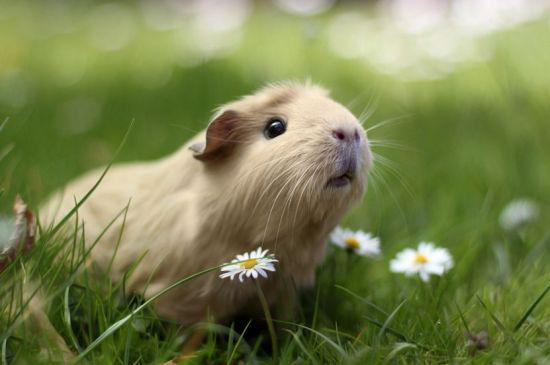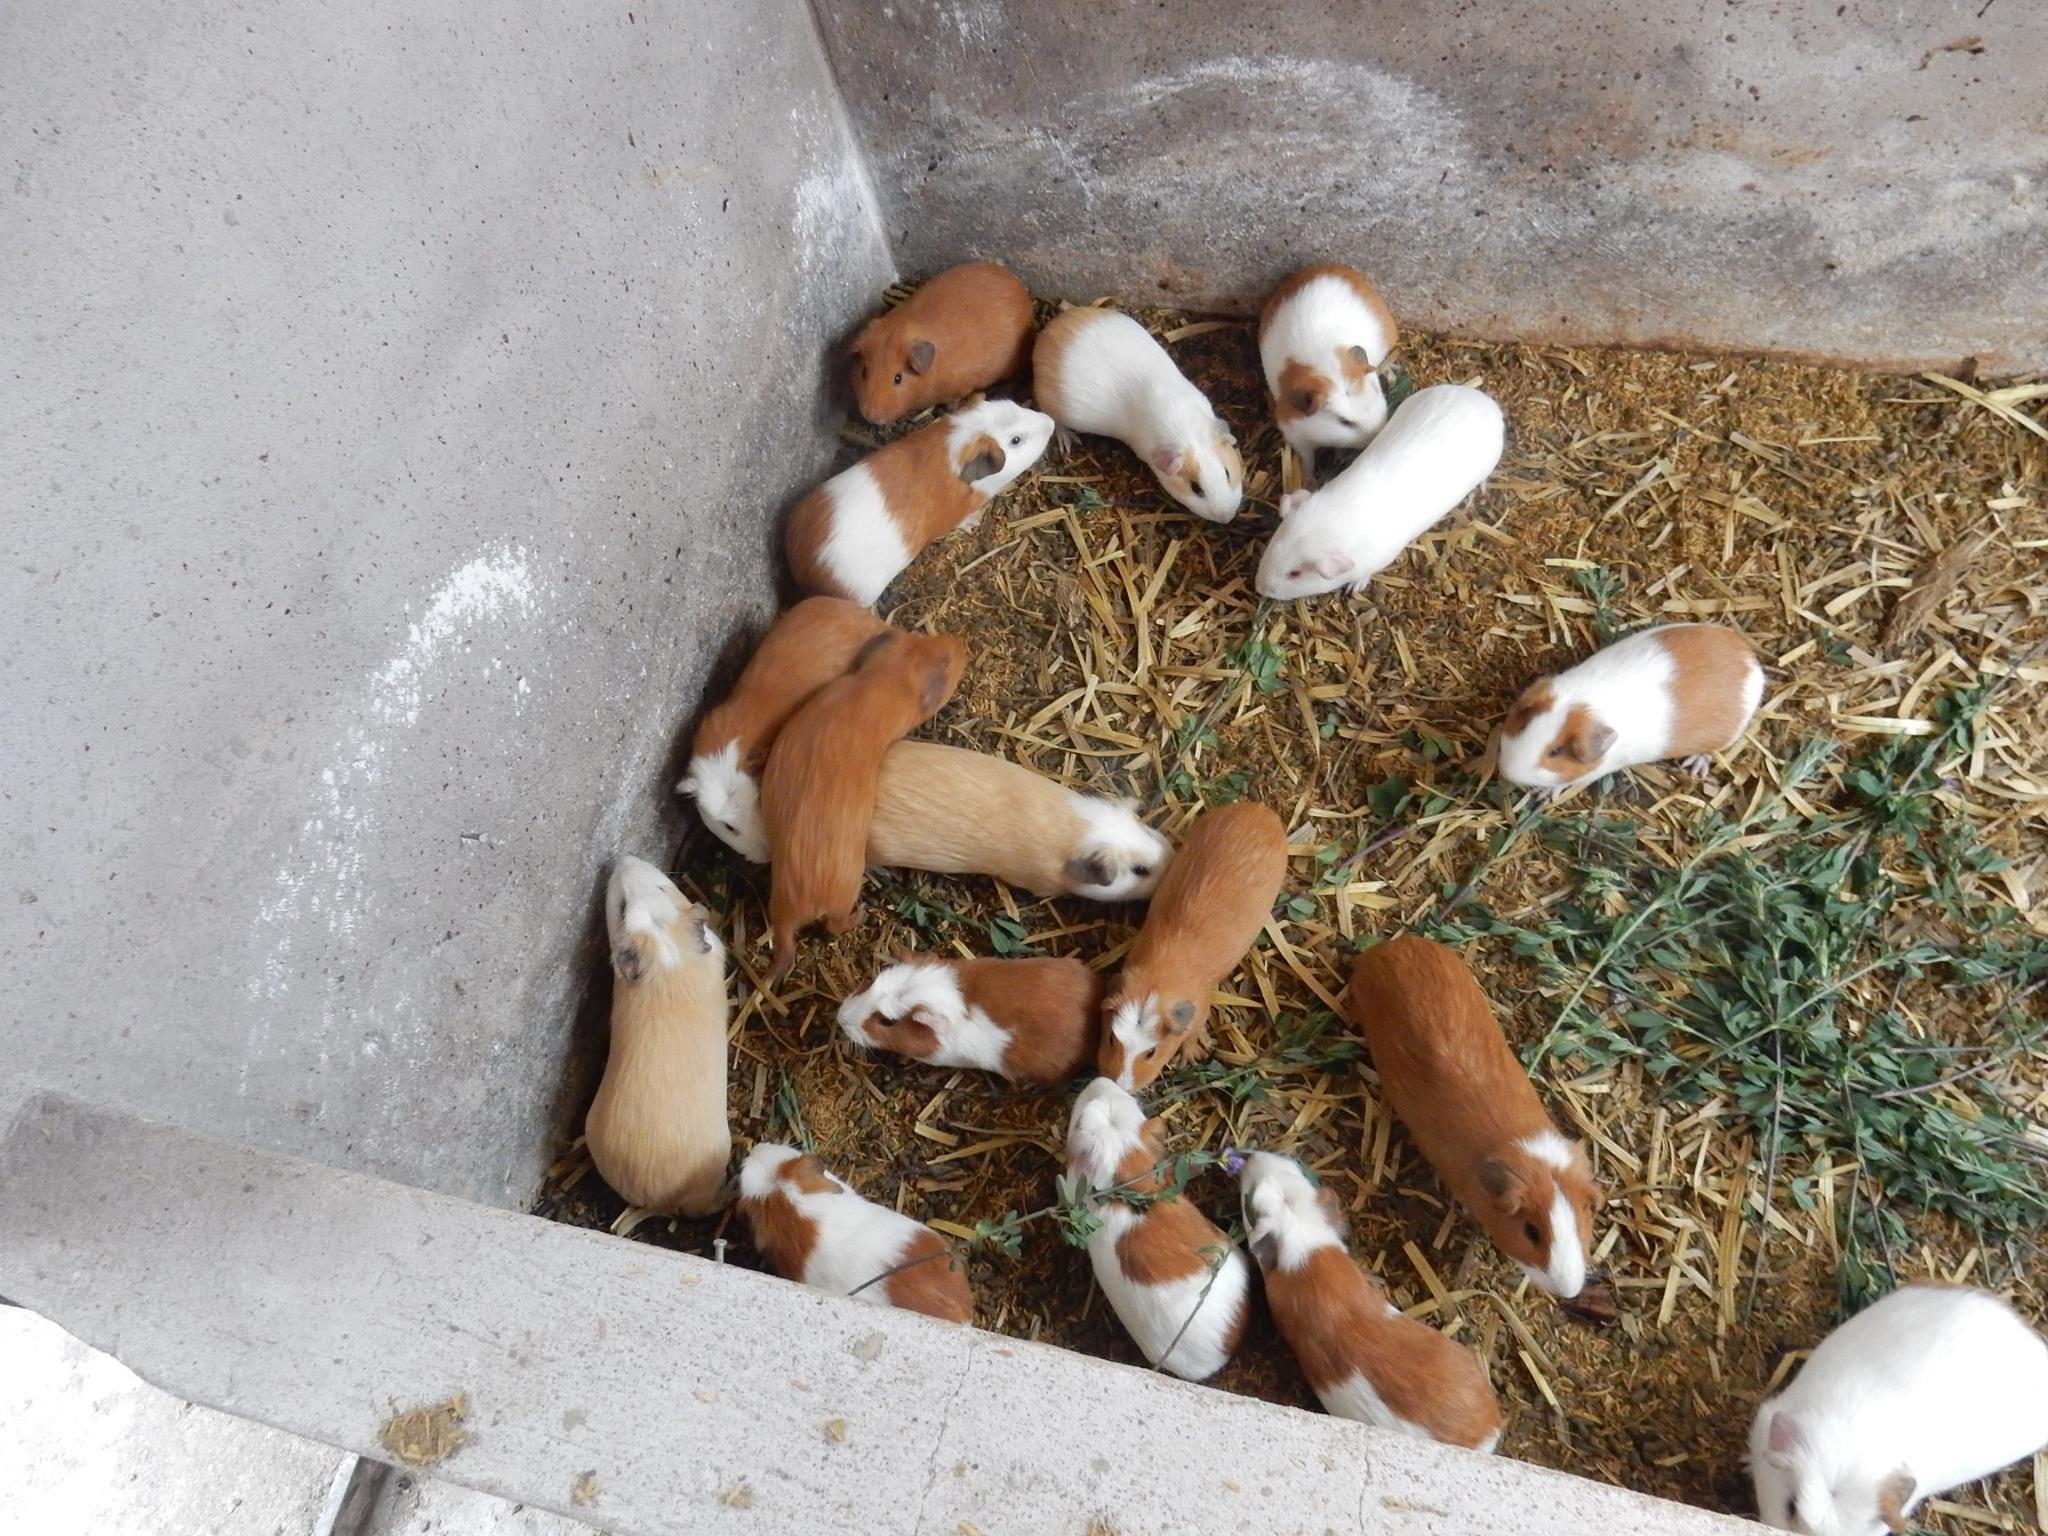The first image is the image on the left, the second image is the image on the right. Evaluate the accuracy of this statement regarding the images: "there are numerous guinea pigs housed in a concrete pen". Is it true? Answer yes or no. Yes. The first image is the image on the left, the second image is the image on the right. Analyze the images presented: Is the assertion "There is a total of 1 guinea pig being displayed with flowers." valid? Answer yes or no. Yes. 